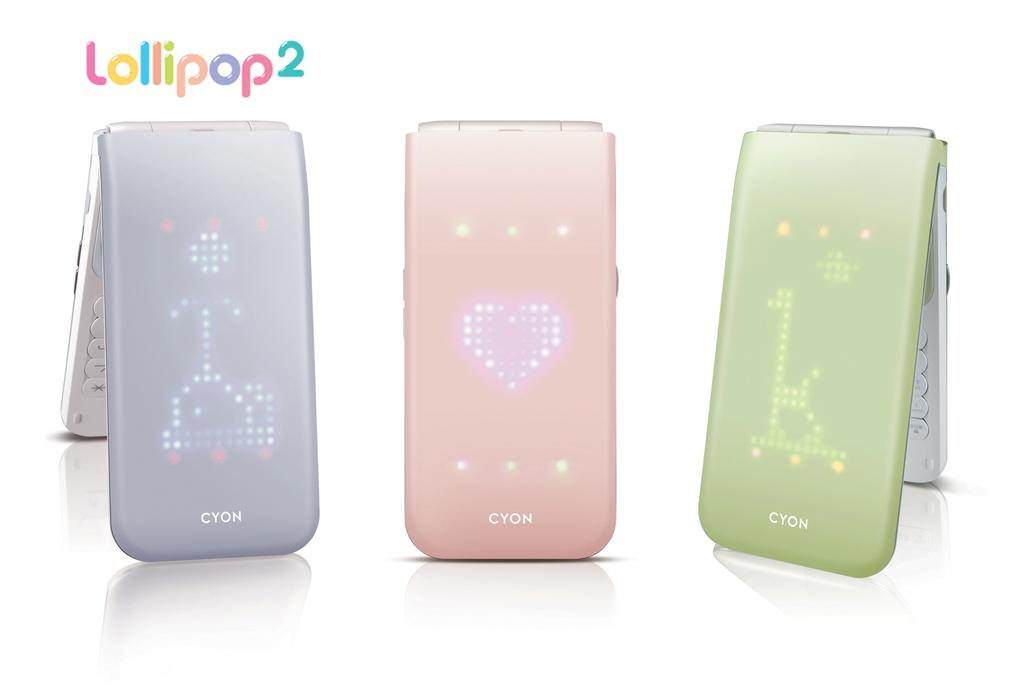What objects are present in the image? There are devices in the image. What can be seen at the top of the image? There is text at the top of the image. What is located at the bottom of the image? There is a table at the bottom of the image. What is reflected on the table in the image? There are reflections of devices on the table. What type of information is present on the devices? There is text on the devices. What arithmetic problem is being solved on the house in the image? There is no house present in the image, and no arithmetic problem is being solved. 